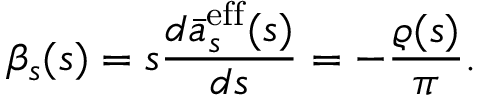<formula> <loc_0><loc_0><loc_500><loc_500>\beta _ { s } ( s ) = s \frac { d \bar { a } _ { s } ^ { e f f } ( s ) } { d s } = - \frac { \varrho ( s ) } { \pi } .</formula> 